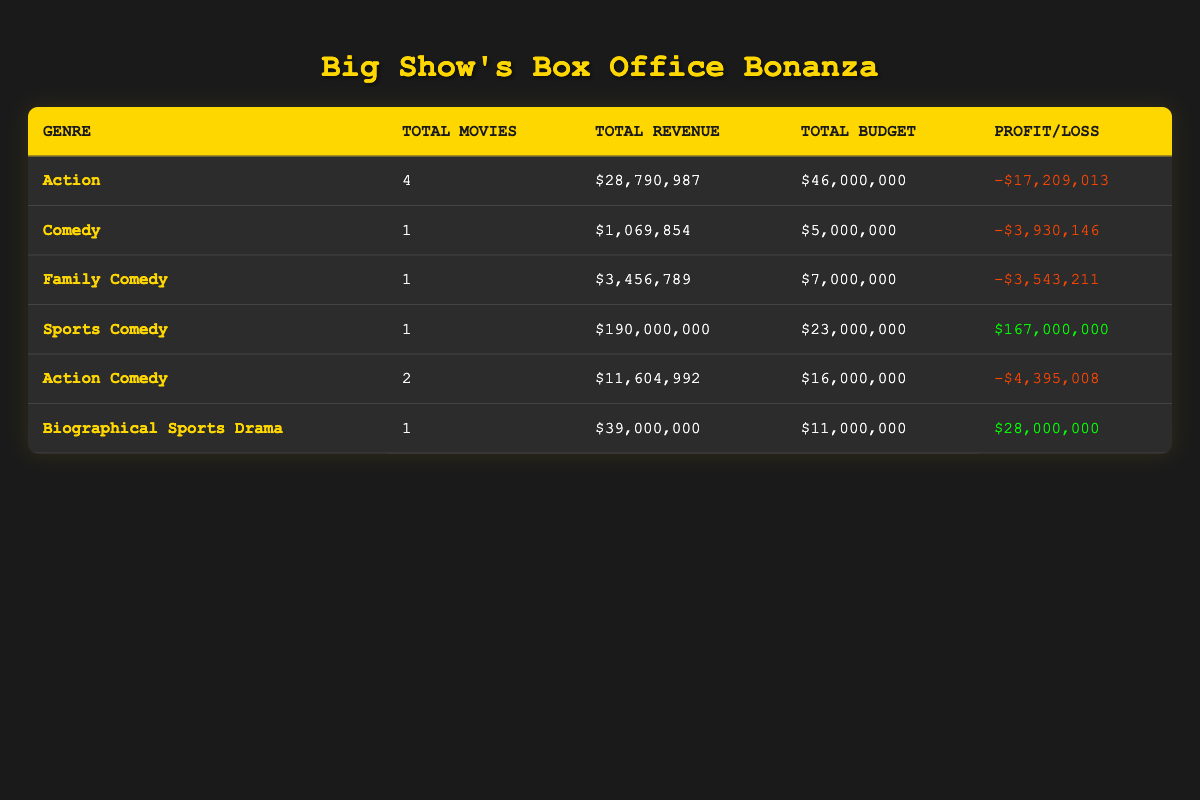What is the total box office revenue for Action genre films? To find the total box office revenue for the Action genre, we look at the corresponding row in the table. The total revenue listed is $28,790,987.
Answer: $28,790,987 How many movies did Big Show star in within the Comedy genre? We can find the number of movies in the Comedy genre by checking the corresponding row in the table. It shows there is 1 movie listed.
Answer: 1 What is the profit or loss for the Sports Comedy genre films? In the row for Sports Comedy, the profit is listed as $167,000,000, indicating a profit as the value is positive.
Answer: $167,000,000 Which genre had the highest total budget? By reviewing the table, we find the Action genre has the highest total budget, which is $46,000,000.
Answer: Action What is the average box office revenue for Action Comedy films? There are 2 Action Comedy films, with a total box office revenue of $11,604,992. To find the average, divide the total by the number of films: $11,604,992 / 2 = $5,802,496.
Answer: $5,802,496 Was there any loss recorded in the Family Comedy genre? Yes, the Family Comedy genre has a loss recorded, as indicated by the negative profit/loss value of -$3,543,211 in the table.
Answer: Yes Which genre has the most movies listed in the table? The Action genre has the most entries in the table, with a total of 4 movies listed.
Answer: Action What is the total profit or loss for all genres combined? To find the total profit or loss, we need to sum the profit and loss across all genres. The total profit/loss amounts to (-$17,209,013) + (-$3,930,146) + (-$3,543,211) + $167,000,000 + (-$4,395,008) + $28,000,000 = $168,922. This indicates a slight overall profit.
Answer: $168,922 How much more was spent on the Action genre compared to the Comedy genre? For Action, the total budget is $46,000,000 and for Comedy, it's $5,000,000. The difference in spending is $46,000,000 - $5,000,000 = $41,000,000.
Answer: $41,000,000 